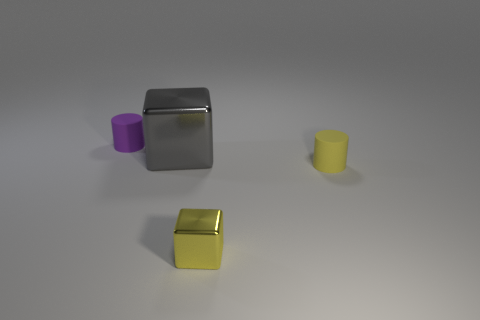Is there anything else that has the same size as the gray object?
Keep it short and to the point. No. What is the size of the gray metallic cube?
Make the answer very short. Large. What number of metal objects are large blocks or large red balls?
Your answer should be compact. 1. There is a matte cylinder that is behind the large shiny object; what number of cylinders are in front of it?
Your answer should be compact. 1. What shape is the tiny object that is both behind the small yellow metal cube and in front of the purple matte object?
Provide a short and direct response. Cylinder. What is the material of the tiny cylinder that is in front of the tiny thing behind the tiny matte cylinder that is in front of the tiny purple cylinder?
Offer a very short reply. Rubber. There is a cylinder that is the same color as the small block; what size is it?
Make the answer very short. Small. What is the large gray block made of?
Keep it short and to the point. Metal. Are the yellow cylinder and the tiny cylinder to the left of the tiny metallic cube made of the same material?
Your response must be concise. Yes. What is the color of the matte thing in front of the cube that is on the left side of the tiny metallic block?
Your answer should be compact. Yellow. 